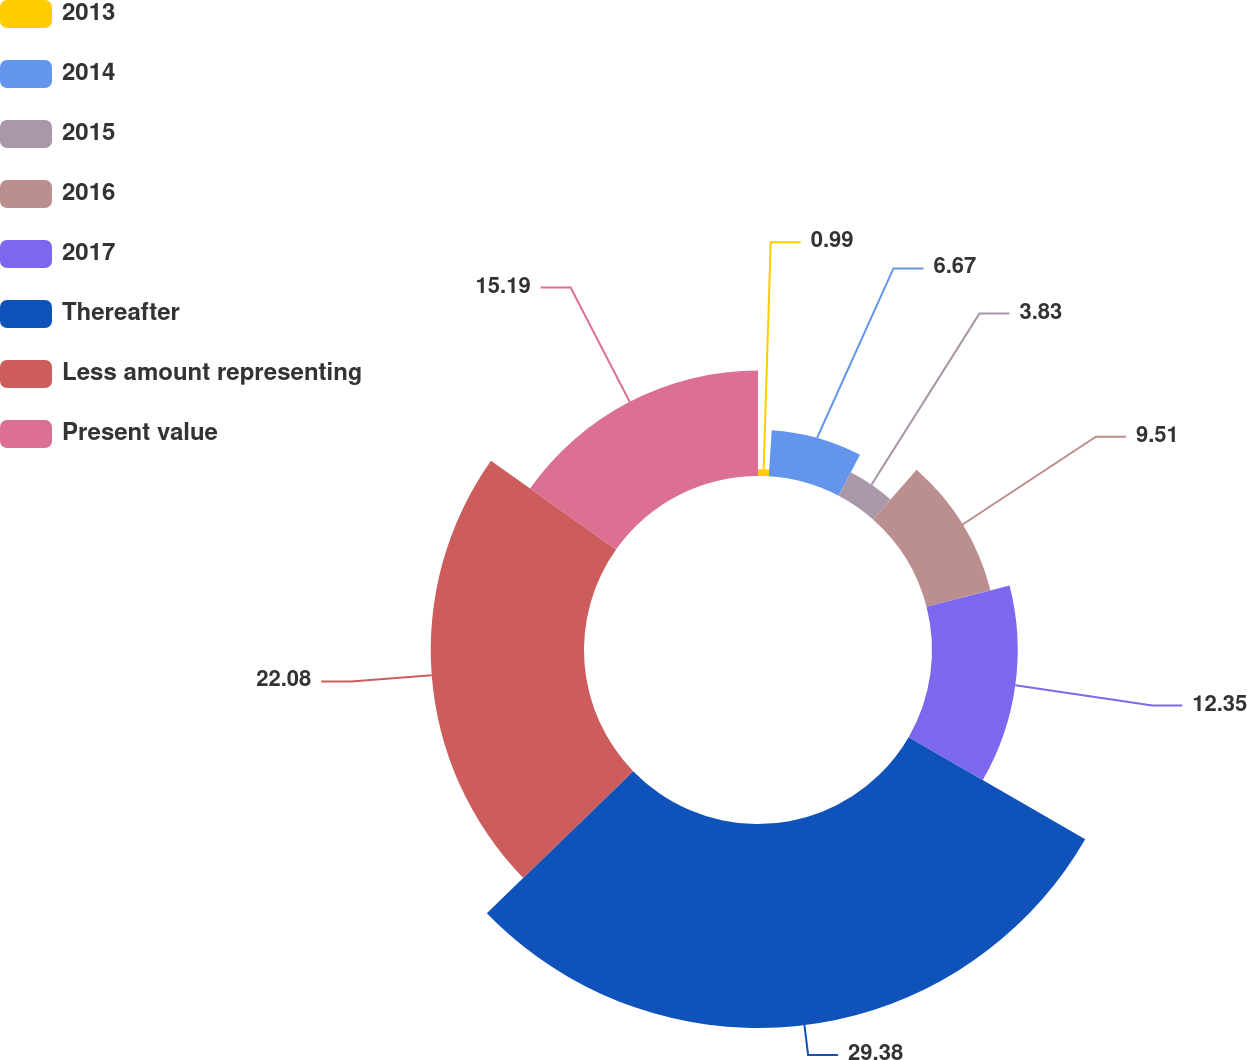Convert chart to OTSL. <chart><loc_0><loc_0><loc_500><loc_500><pie_chart><fcel>2013<fcel>2014<fcel>2015<fcel>2016<fcel>2017<fcel>Thereafter<fcel>Less amount representing<fcel>Present value<nl><fcel>0.99%<fcel>6.67%<fcel>3.83%<fcel>9.51%<fcel>12.35%<fcel>29.39%<fcel>22.08%<fcel>15.19%<nl></chart> 